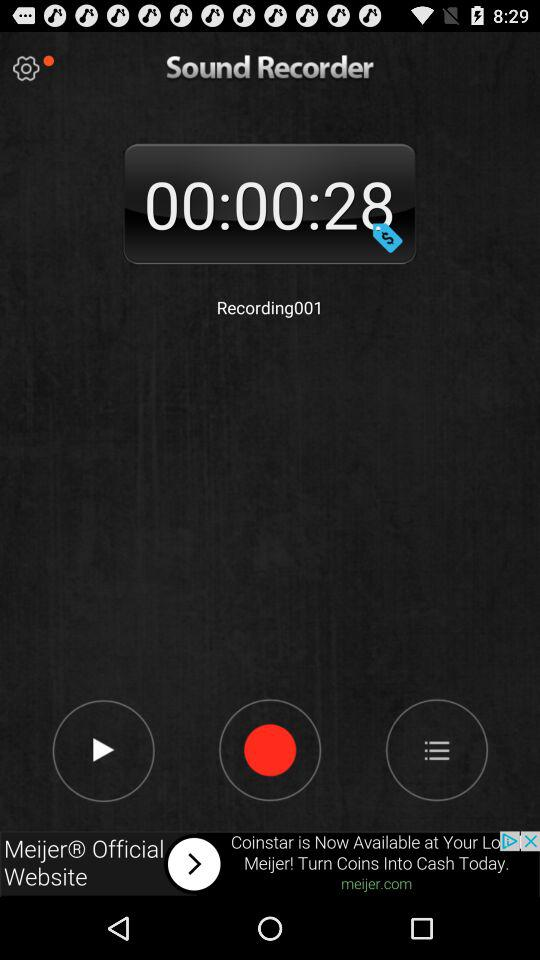What is the recording time of a sound recorder? The recording time is 00:00:28. 